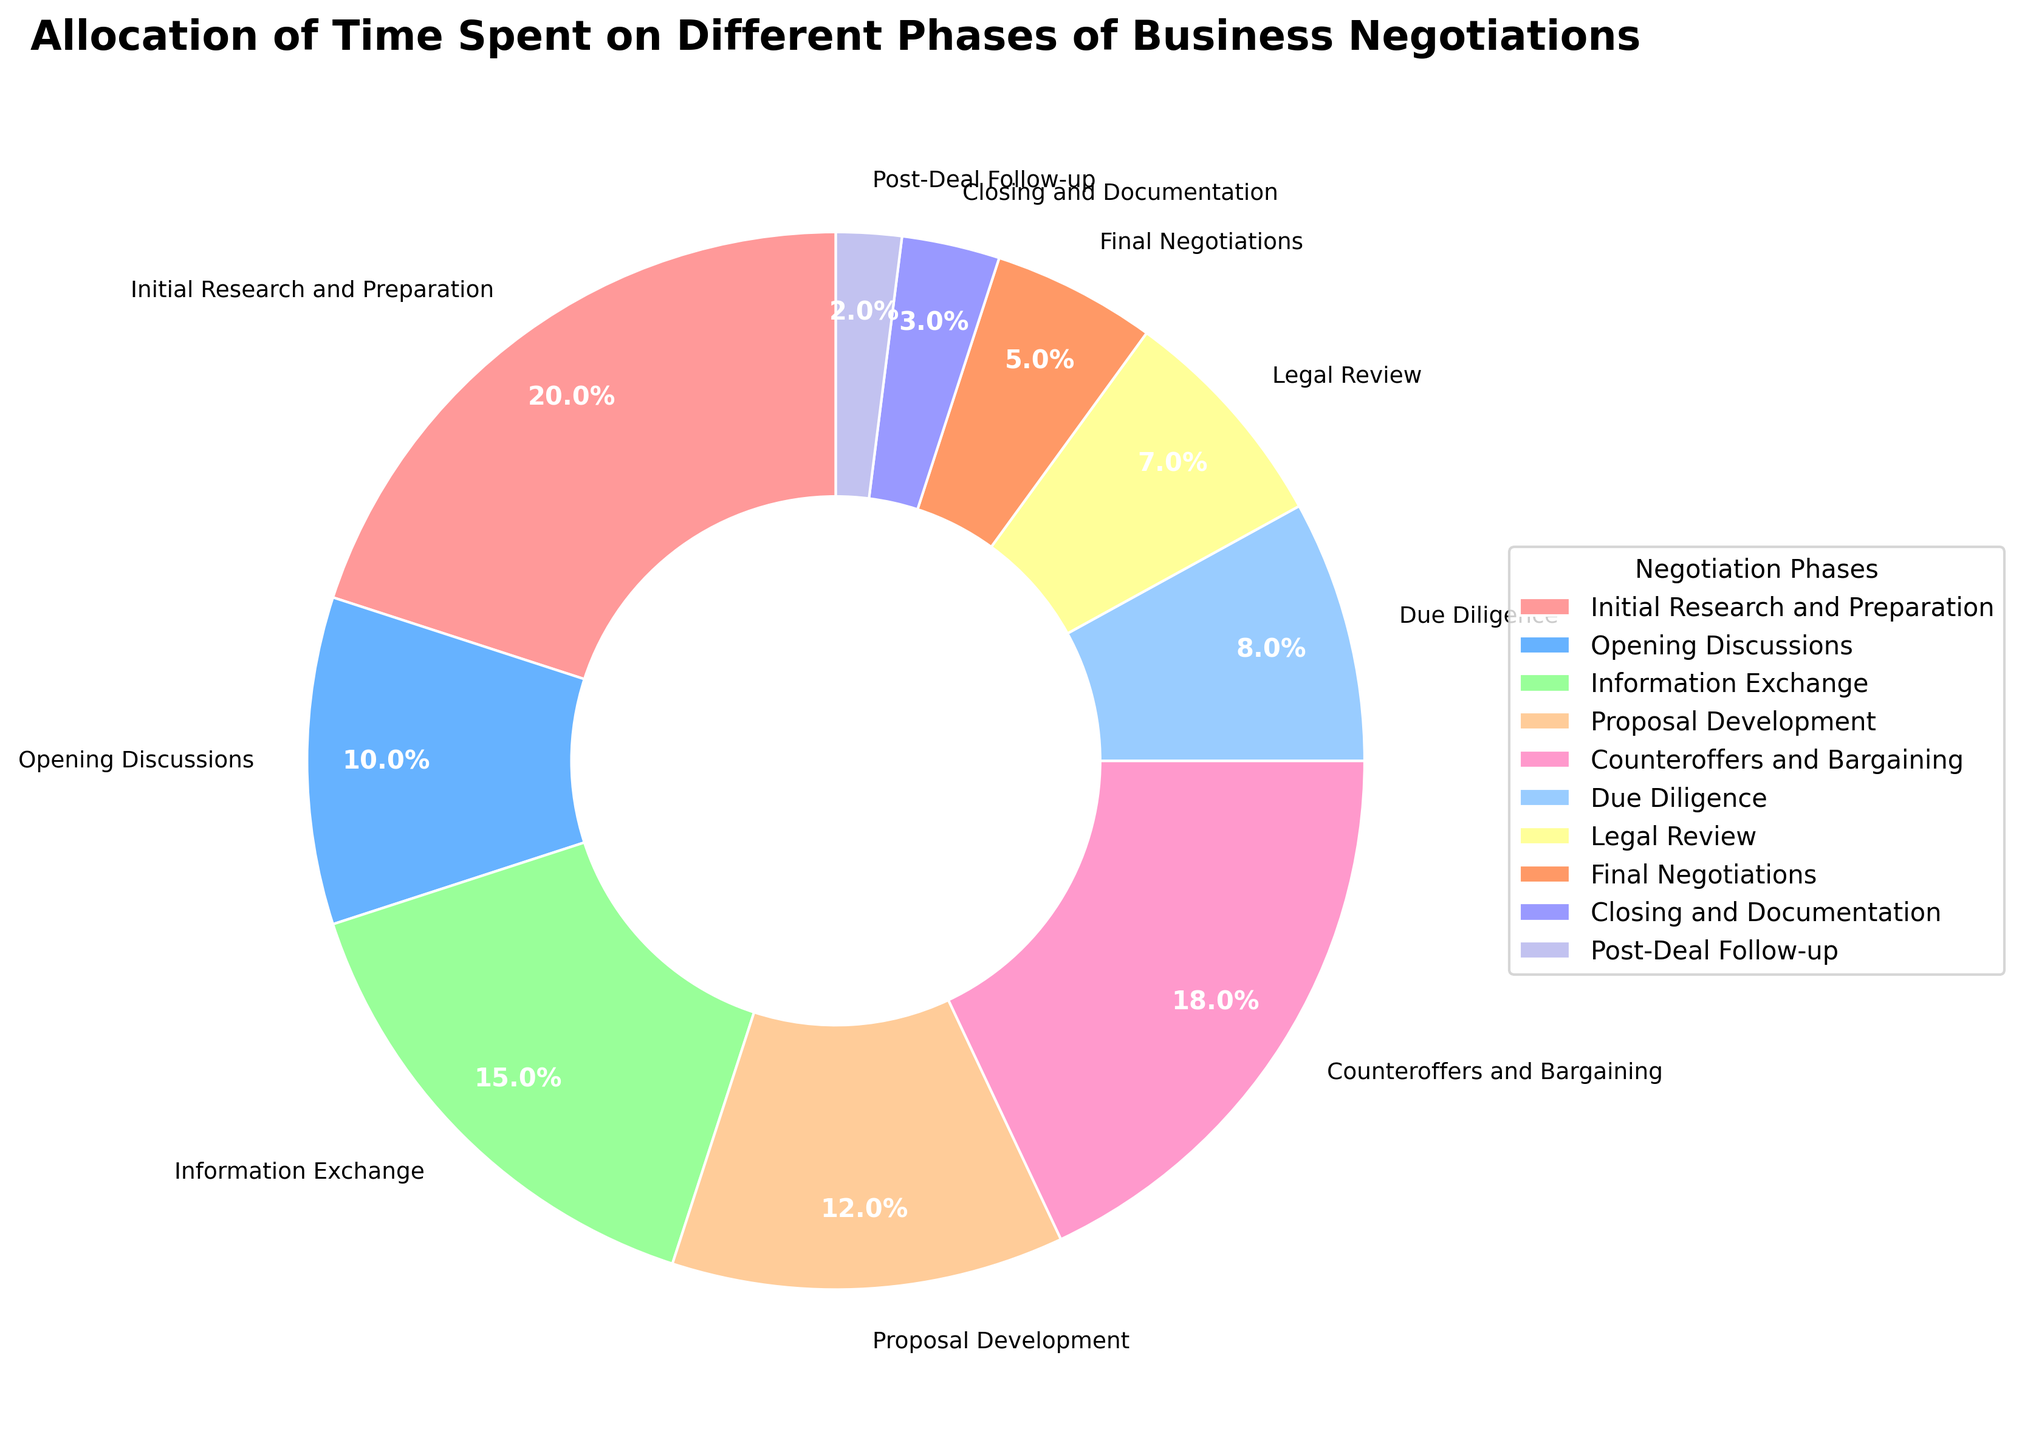What percentage of time is spent on Initial Research and Preparation and Information Exchange combined? To find the total time spent on Initial Research and Preparation and Information Exchange, sum the percentages for these two phases: 20% (Initial Research and Preparation) + 15% (Information Exchange) = 35%.
Answer: 35% Which phase of the negotiation process is allocated the least amount of time? By examining the pie chart, the phase with the smallest slice corresponds to Post-Deal Follow-up, which shows 2%.
Answer: Post-Deal Follow-up What is the difference in time allocation between Due Diligence and Legal Review? Subtract the percentage for Legal Review from the percentage for Due Diligence: 8% (Due Diligence) - 7% (Legal Review) = 1%.
Answer: 1% Is the time spent on Counteroffers and Bargaining greater than the time spent on Proposal Development? Compare the percentages for both phases: Counteroffers and Bargaining is 18%, while Proposal Development is 12%, which means Counteroffers and Bargaining is greater.
Answer: Yes How does the time allocated to Opening Discussions compare to Final Negotiations? Compare the percentages for Opening Discussions and Final Negotiations: 10% (Opening Discussions) vs. 5% (Final Negotiations). Opening Discussions has double the time allocation of Final Negotiations.
Answer: Double What is the total percentage of time allocated to Closing and Documentation, and Post-Deal Follow-up? Add the percentages for Closing and Documentation and Post-Deal Follow-up: 3% (Closing and Documentation) + 2% (Post-Deal Follow-up) = 5%.
Answer: 5% Are there more phases with time allocation greater than or equal to 10% or phases with time allocation less than 10%? Count the phases in each category: The phases with ≥10% are Initial Research and Preparation (20%), Opening Discussions (10%), Information Exchange (15%), Proposal Development (12%), and Counteroffers and Bargaining (18%) — totaling 5 phases. The phases with <10% are Due Diligence (8%), Legal Review (7%), Final Negotiations (5%), Closing and Documentation (3%), and Post-Deal Follow-up (2%) — also totaling 5 phases.
Answer: Equal Which phases have slices with a noticeable custom color of green? By looking at the visual representation of colors in the pie chart, the phase Information Exchange corresponds to a noticeable green color.
Answer: Information Exchange What percentage or more of time is spent on phases involving direct interaction (Opening Discussions, Information Exchange, Counteroffers and Bargaining, Final Negotiations)? Sum the percentages for these phases: 10% (Opening Discussions) + 15% (Information Exchange) + 18% (Counteroffers and Bargaining) + 5% (Final Negotiations) = 48%.
Answer: 48% 